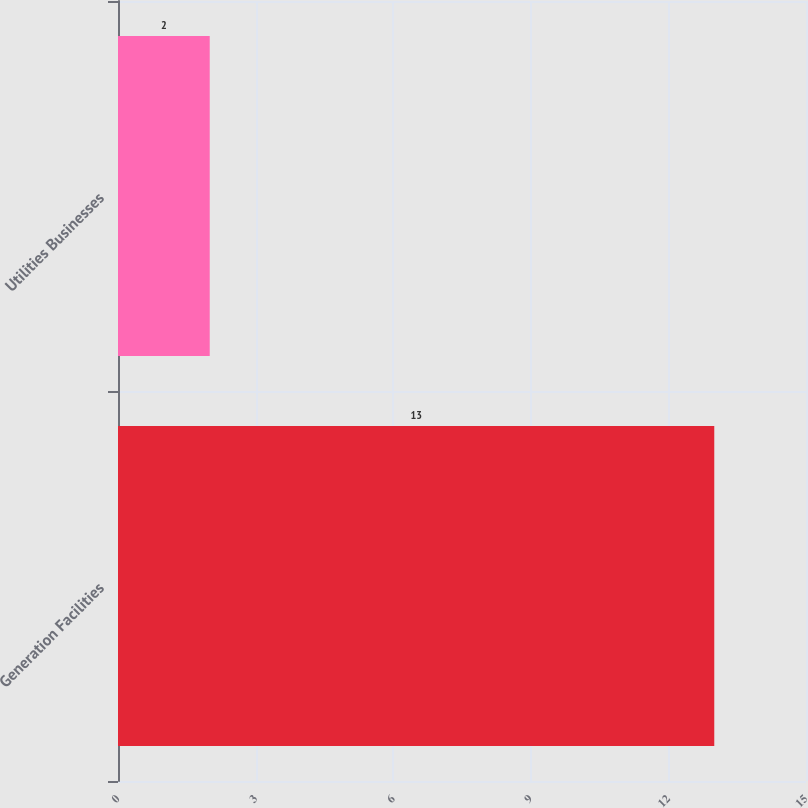Convert chart. <chart><loc_0><loc_0><loc_500><loc_500><bar_chart><fcel>Generation Facilities<fcel>Utilities Businesses<nl><fcel>13<fcel>2<nl></chart> 